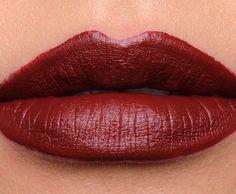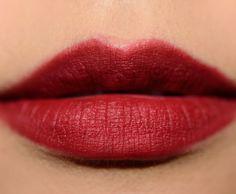The first image is the image on the left, the second image is the image on the right. For the images displayed, is the sentence "One image includes a lip makeup item and at least one pair of tinted lips, and the other image contains at least one pair of tinted lips but no lip makeup item." factually correct? Answer yes or no. No. The first image is the image on the left, the second image is the image on the right. For the images displayed, is the sentence "A single pair of lips is wearing lipstick in each of the images." factually correct? Answer yes or no. Yes. 